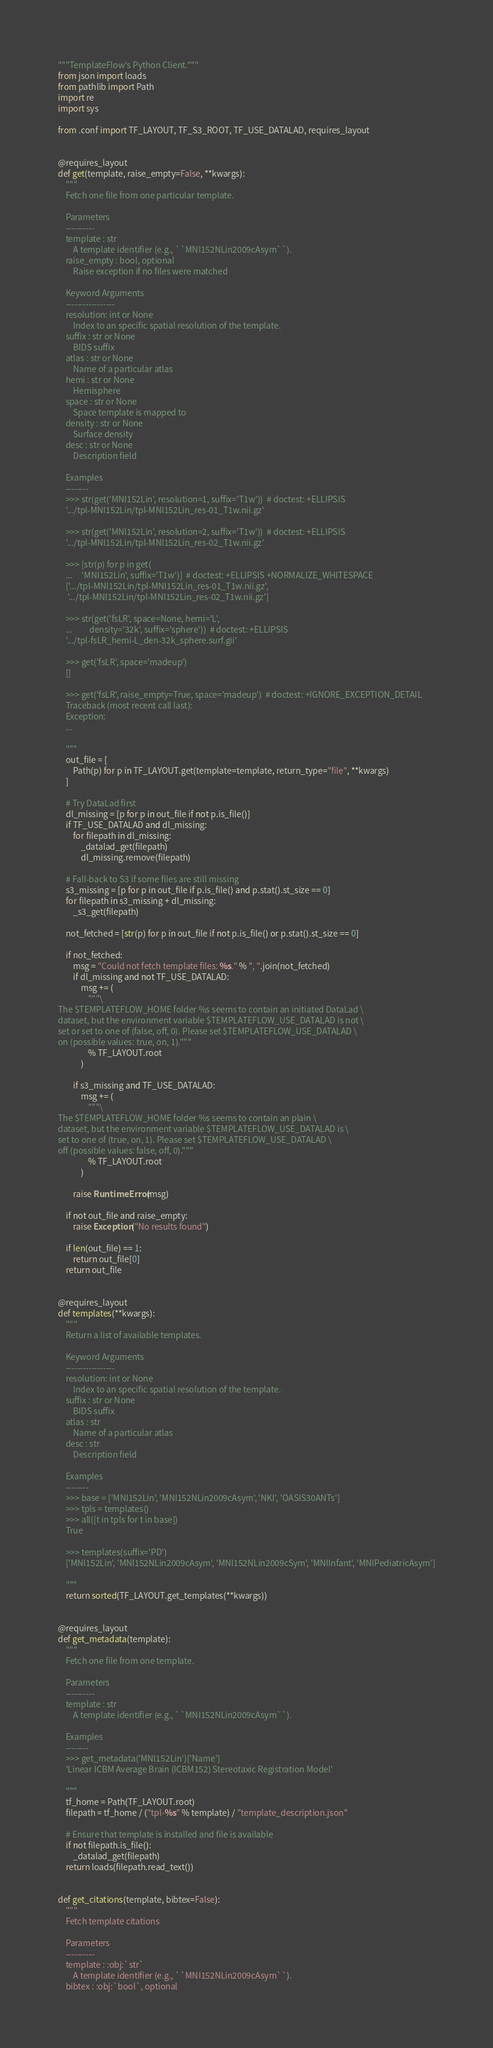Convert code to text. <code><loc_0><loc_0><loc_500><loc_500><_Python_>"""TemplateFlow's Python Client."""
from json import loads
from pathlib import Path
import re
import sys

from .conf import TF_LAYOUT, TF_S3_ROOT, TF_USE_DATALAD, requires_layout


@requires_layout
def get(template, raise_empty=False, **kwargs):
    """
    Fetch one file from one particular template.

    Parameters
    ----------
    template : str
        A template identifier (e.g., ``MNI152NLin2009cAsym``).
    raise_empty : bool, optional
        Raise exception if no files were matched

    Keyword Arguments
    -----------------
    resolution: int or None
        Index to an specific spatial resolution of the template.
    suffix : str or None
        BIDS suffix
    atlas : str or None
        Name of a particular atlas
    hemi : str or None
        Hemisphere
    space : str or None
        Space template is mapped to
    density : str or None
        Surface density
    desc : str or None
        Description field

    Examples
    --------
    >>> str(get('MNI152Lin', resolution=1, suffix='T1w'))  # doctest: +ELLIPSIS
    '.../tpl-MNI152Lin/tpl-MNI152Lin_res-01_T1w.nii.gz'

    >>> str(get('MNI152Lin', resolution=2, suffix='T1w'))  # doctest: +ELLIPSIS
    '.../tpl-MNI152Lin/tpl-MNI152Lin_res-02_T1w.nii.gz'

    >>> [str(p) for p in get(
    ...     'MNI152Lin', suffix='T1w')]  # doctest: +ELLIPSIS +NORMALIZE_WHITESPACE
    ['.../tpl-MNI152Lin/tpl-MNI152Lin_res-01_T1w.nii.gz',
     '.../tpl-MNI152Lin/tpl-MNI152Lin_res-02_T1w.nii.gz']

    >>> str(get('fsLR', space=None, hemi='L',
    ...         density='32k', suffix='sphere'))  # doctest: +ELLIPSIS
    '.../tpl-fsLR_hemi-L_den-32k_sphere.surf.gii'

    >>> get('fsLR', space='madeup')
    []

    >>> get('fsLR', raise_empty=True, space='madeup')  # doctest: +IGNORE_EXCEPTION_DETAIL
    Traceback (most recent call last):
    Exception:
    ...

    """
    out_file = [
        Path(p) for p in TF_LAYOUT.get(template=template, return_type="file", **kwargs)
    ]

    # Try DataLad first
    dl_missing = [p for p in out_file if not p.is_file()]
    if TF_USE_DATALAD and dl_missing:
        for filepath in dl_missing:
            _datalad_get(filepath)
            dl_missing.remove(filepath)

    # Fall-back to S3 if some files are still missing
    s3_missing = [p for p in out_file if p.is_file() and p.stat().st_size == 0]
    for filepath in s3_missing + dl_missing:
        _s3_get(filepath)

    not_fetched = [str(p) for p in out_file if not p.is_file() or p.stat().st_size == 0]

    if not_fetched:
        msg = "Could not fetch template files: %s." % ", ".join(not_fetched)
        if dl_missing and not TF_USE_DATALAD:
            msg += (
                """\
The $TEMPLATEFLOW_HOME folder %s seems to contain an initiated DataLad \
dataset, but the environment variable $TEMPLATEFLOW_USE_DATALAD is not \
set or set to one of (false, off, 0). Please set $TEMPLATEFLOW_USE_DATALAD \
on (possible values: true, on, 1)."""
                % TF_LAYOUT.root
            )

        if s3_missing and TF_USE_DATALAD:
            msg += (
                """\
The $TEMPLATEFLOW_HOME folder %s seems to contain an plain \
dataset, but the environment variable $TEMPLATEFLOW_USE_DATALAD is \
set to one of (true, on, 1). Please set $TEMPLATEFLOW_USE_DATALAD \
off (possible values: false, off, 0)."""
                % TF_LAYOUT.root
            )

        raise RuntimeError(msg)

    if not out_file and raise_empty:
        raise Exception("No results found")

    if len(out_file) == 1:
        return out_file[0]
    return out_file


@requires_layout
def templates(**kwargs):
    """
    Return a list of available templates.

    Keyword Arguments
    -----------------
    resolution: int or None
        Index to an specific spatial resolution of the template.
    suffix : str or None
        BIDS suffix
    atlas : str
        Name of a particular atlas
    desc : str
        Description field

    Examples
    --------
    >>> base = ['MNI152Lin', 'MNI152NLin2009cAsym', 'NKI', 'OASIS30ANTs']
    >>> tpls = templates()
    >>> all([t in tpls for t in base])
    True

    >>> templates(suffix='PD')
    ['MNI152Lin', 'MNI152NLin2009cAsym', 'MNI152NLin2009cSym', 'MNIInfant', 'MNIPediatricAsym']

    """
    return sorted(TF_LAYOUT.get_templates(**kwargs))


@requires_layout
def get_metadata(template):
    """
    Fetch one file from one template.

    Parameters
    ----------
    template : str
        A template identifier (e.g., ``MNI152NLin2009cAsym``).

    Examples
    --------
    >>> get_metadata('MNI152Lin')['Name']
    'Linear ICBM Average Brain (ICBM152) Stereotaxic Registration Model'

    """
    tf_home = Path(TF_LAYOUT.root)
    filepath = tf_home / ("tpl-%s" % template) / "template_description.json"

    # Ensure that template is installed and file is available
    if not filepath.is_file():
        _datalad_get(filepath)
    return loads(filepath.read_text())


def get_citations(template, bibtex=False):
    """
    Fetch template citations

    Parameters
    ----------
    template : :obj:`str`
        A template identifier (e.g., ``MNI152NLin2009cAsym``).
    bibtex : :obj:`bool`, optional</code> 